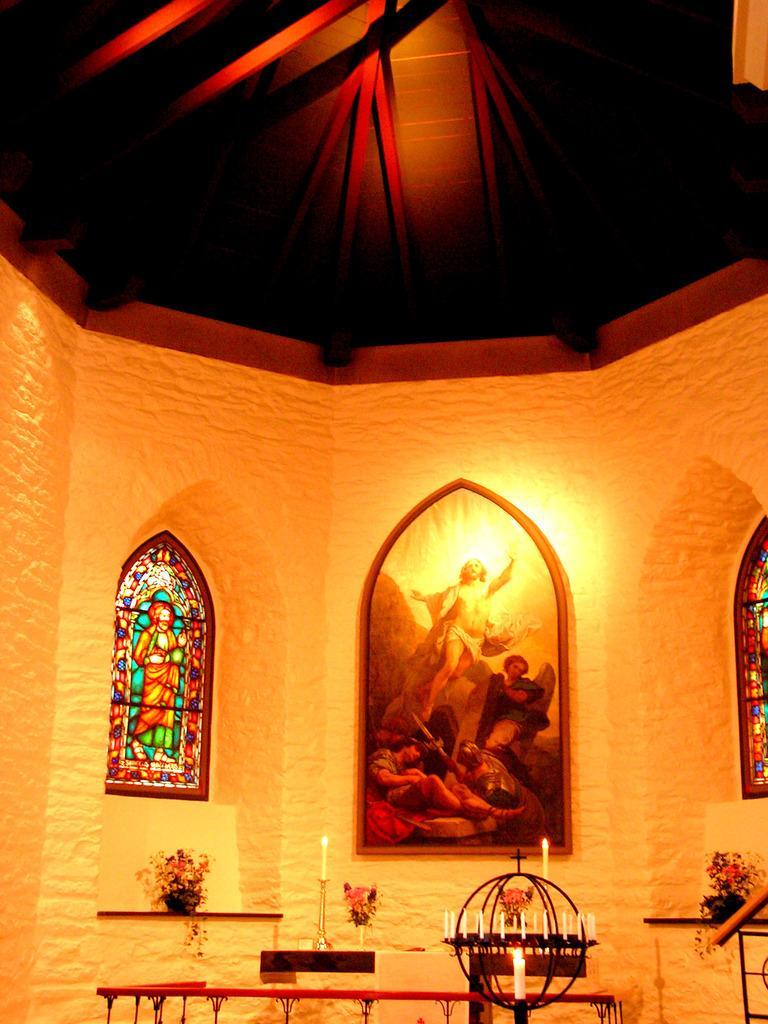How would you summarize this image in a sentence or two? In this picture, we can see the wall with some images, we can see some objects at bottom side of the picture, like tables and some objects on the table like candles, candle holders, plants in pots, and we can see lights, and roof with poles. 